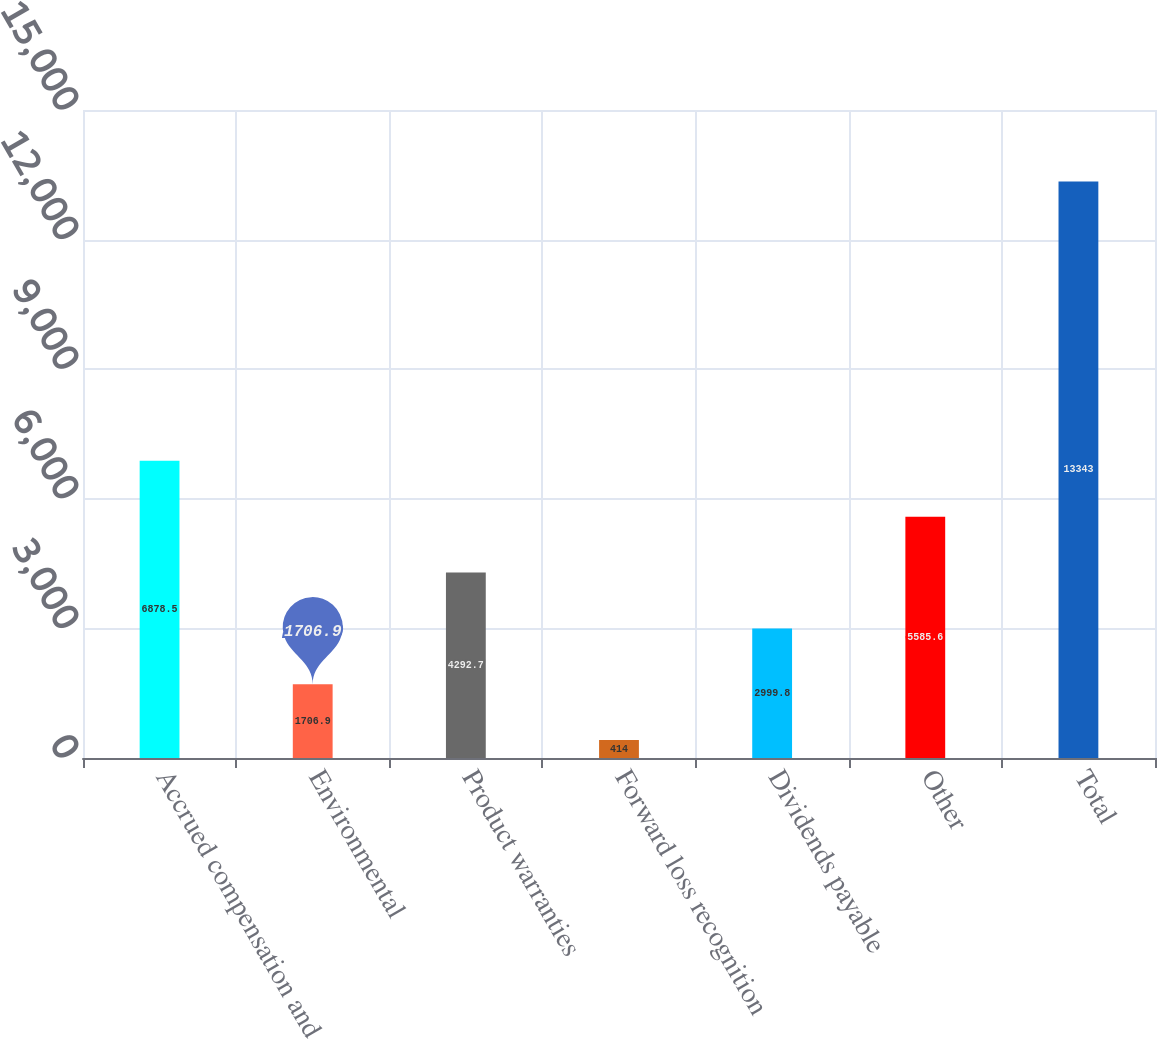Convert chart. <chart><loc_0><loc_0><loc_500><loc_500><bar_chart><fcel>Accrued compensation and<fcel>Environmental<fcel>Product warranties<fcel>Forward loss recognition<fcel>Dividends payable<fcel>Other<fcel>Total<nl><fcel>6878.5<fcel>1706.9<fcel>4292.7<fcel>414<fcel>2999.8<fcel>5585.6<fcel>13343<nl></chart> 